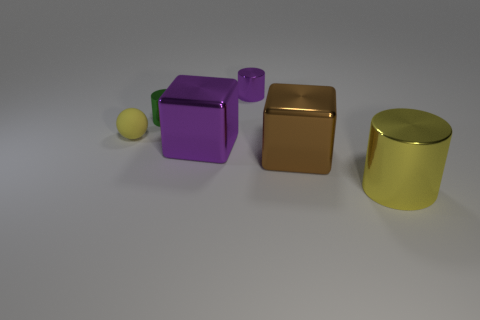Add 4 small green rubber blocks. How many objects exist? 10 Subtract all cubes. How many objects are left? 4 Subtract 1 green cylinders. How many objects are left? 5 Subtract all green objects. Subtract all large shiny blocks. How many objects are left? 3 Add 6 tiny purple shiny cylinders. How many tiny purple shiny cylinders are left? 7 Add 6 big brown blocks. How many big brown blocks exist? 7 